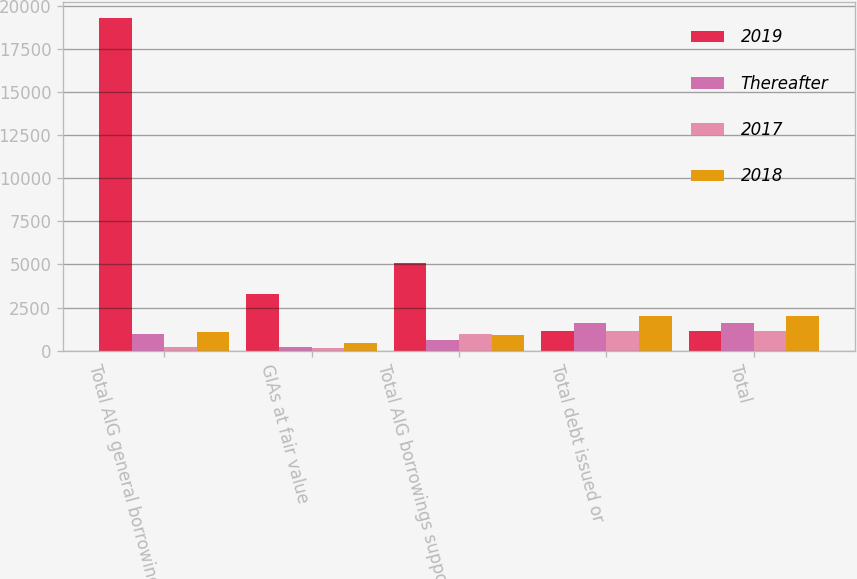Convert chart. <chart><loc_0><loc_0><loc_500><loc_500><stacked_bar_chart><ecel><fcel>Total AIG general borrowings<fcel>GIAs at fair value<fcel>Total AIG borrowings supported<fcel>Total debt issued or<fcel>Total<nl><fcel>2019<fcel>19285<fcel>3276<fcel>5076<fcel>1137.5<fcel>1137.5<nl><fcel>Thereafter<fcel>992<fcel>190<fcel>627<fcel>1619<fcel>1619<nl><fcel>2017<fcel>192<fcel>176<fcel>977<fcel>1169<fcel>1171<nl><fcel>2018<fcel>1106<fcel>464<fcel>933<fcel>2039<fcel>2039<nl></chart> 